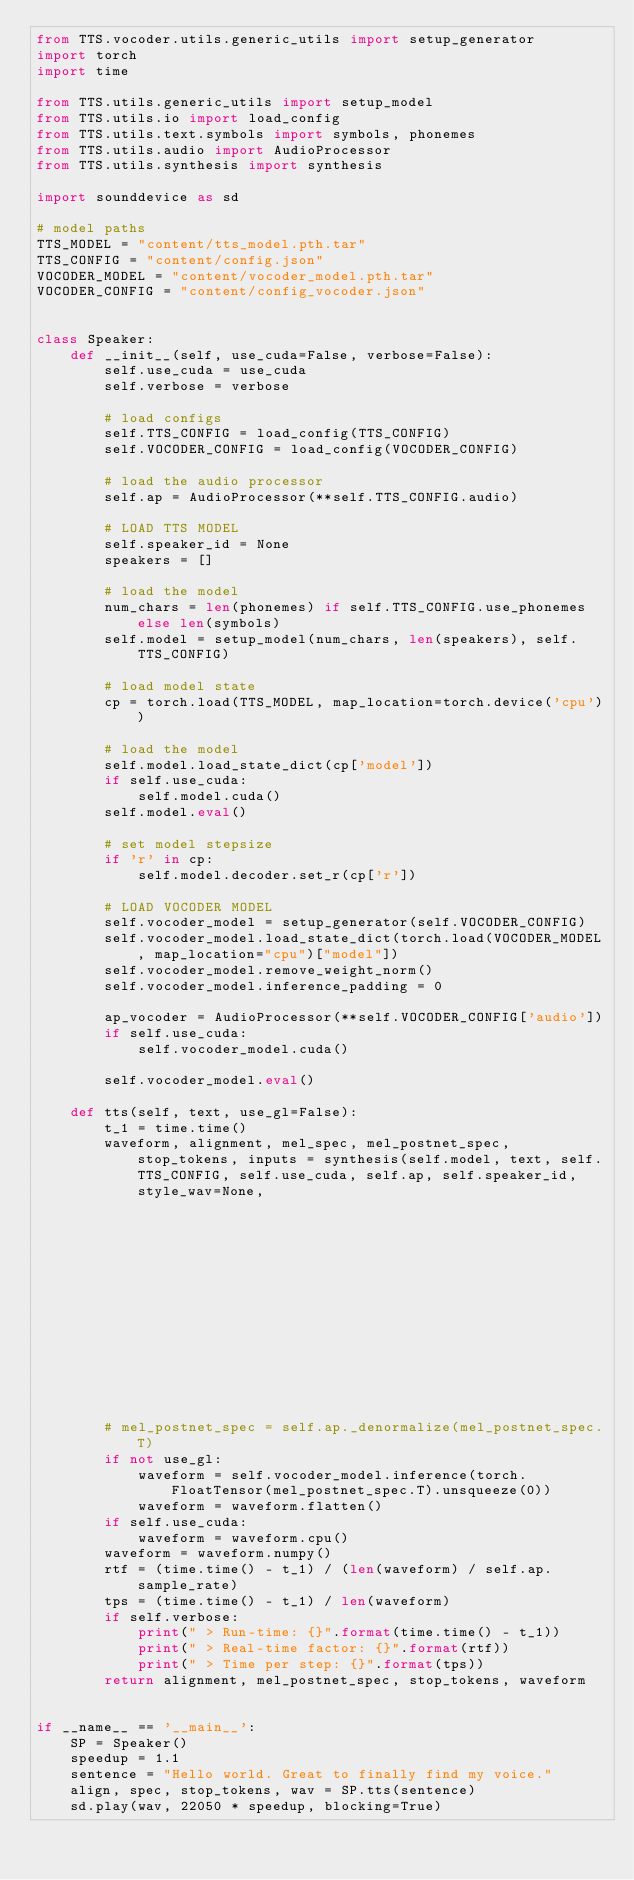Convert code to text. <code><loc_0><loc_0><loc_500><loc_500><_Python_>from TTS.vocoder.utils.generic_utils import setup_generator
import torch
import time

from TTS.utils.generic_utils import setup_model
from TTS.utils.io import load_config
from TTS.utils.text.symbols import symbols, phonemes
from TTS.utils.audio import AudioProcessor
from TTS.utils.synthesis import synthesis

import sounddevice as sd

# model paths
TTS_MODEL = "content/tts_model.pth.tar"
TTS_CONFIG = "content/config.json"
VOCODER_MODEL = "content/vocoder_model.pth.tar"
VOCODER_CONFIG = "content/config_vocoder.json"


class Speaker:
    def __init__(self, use_cuda=False, verbose=False):
        self.use_cuda = use_cuda
        self.verbose = verbose

        # load configs
        self.TTS_CONFIG = load_config(TTS_CONFIG)
        self.VOCODER_CONFIG = load_config(VOCODER_CONFIG)

        # load the audio processor
        self.ap = AudioProcessor(**self.TTS_CONFIG.audio)

        # LOAD TTS MODEL
        self.speaker_id = None
        speakers = []

        # load the model
        num_chars = len(phonemes) if self.TTS_CONFIG.use_phonemes else len(symbols)
        self.model = setup_model(num_chars, len(speakers), self.TTS_CONFIG)

        # load model state
        cp = torch.load(TTS_MODEL, map_location=torch.device('cpu'))

        # load the model
        self.model.load_state_dict(cp['model'])
        if self.use_cuda:
            self.model.cuda()
        self.model.eval()

        # set model stepsize
        if 'r' in cp:
            self.model.decoder.set_r(cp['r'])

        # LOAD VOCODER MODEL
        self.vocoder_model = setup_generator(self.VOCODER_CONFIG)
        self.vocoder_model.load_state_dict(torch.load(VOCODER_MODEL, map_location="cpu")["model"])
        self.vocoder_model.remove_weight_norm()
        self.vocoder_model.inference_padding = 0

        ap_vocoder = AudioProcessor(**self.VOCODER_CONFIG['audio'])
        if self.use_cuda:
            self.vocoder_model.cuda()

        self.vocoder_model.eval()

    def tts(self, text, use_gl=False):
        t_1 = time.time()
        waveform, alignment, mel_spec, mel_postnet_spec, stop_tokens, inputs = synthesis(self.model, text, self.TTS_CONFIG, self.use_cuda, self.ap, self.speaker_id, style_wav=None,
                                                                                         truncated=False, enable_eos_bos_chars=self.TTS_CONFIG.enable_eos_bos_chars)
        # mel_postnet_spec = self.ap._denormalize(mel_postnet_spec.T)
        if not use_gl:
            waveform = self.vocoder_model.inference(torch.FloatTensor(mel_postnet_spec.T).unsqueeze(0))
            waveform = waveform.flatten()
        if self.use_cuda:
            waveform = waveform.cpu()
        waveform = waveform.numpy()
        rtf = (time.time() - t_1) / (len(waveform) / self.ap.sample_rate)
        tps = (time.time() - t_1) / len(waveform)
        if self.verbose:
            print(" > Run-time: {}".format(time.time() - t_1))
            print(" > Real-time factor: {}".format(rtf))
            print(" > Time per step: {}".format(tps))
        return alignment, mel_postnet_spec, stop_tokens, waveform


if __name__ == '__main__':
    SP = Speaker()
    speedup = 1.1
    sentence = "Hello world. Great to finally find my voice."
    align, spec, stop_tokens, wav = SP.tts(sentence)
    sd.play(wav, 22050 * speedup, blocking=True)
</code> 